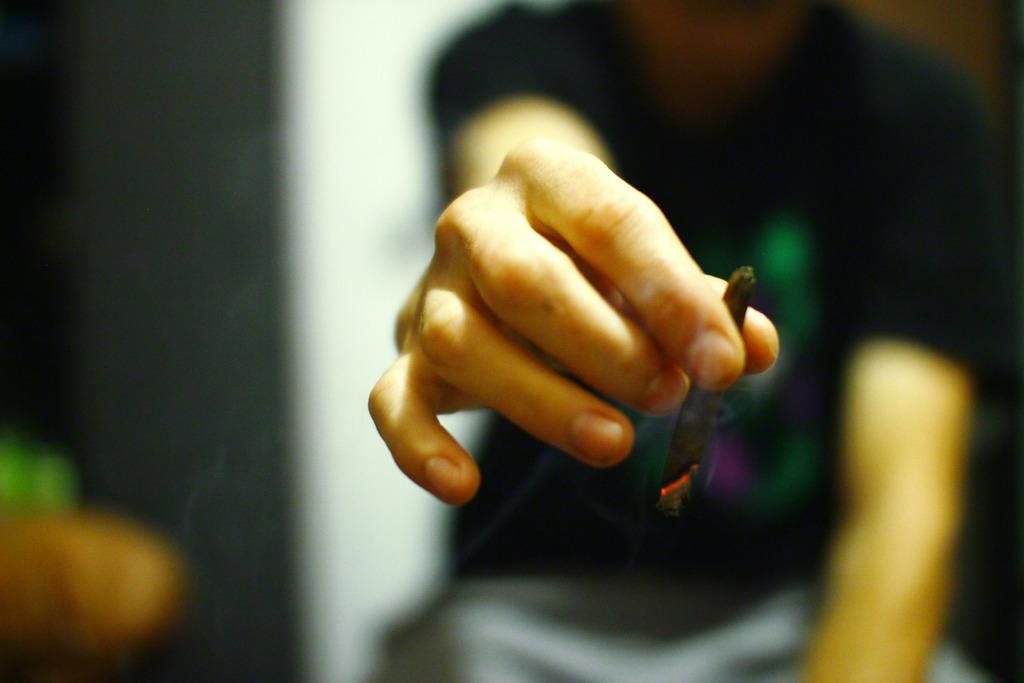What is the main subject of the image? There is a person in the image. What is the person holding in the image? The person is holding a cigarette. Can you describe the background of the image? The background of the image is blurred. What type of magic trick is the person performing in the image? There is no indication of a magic trick being performed in the image. The person is simply holding a cigarette. 